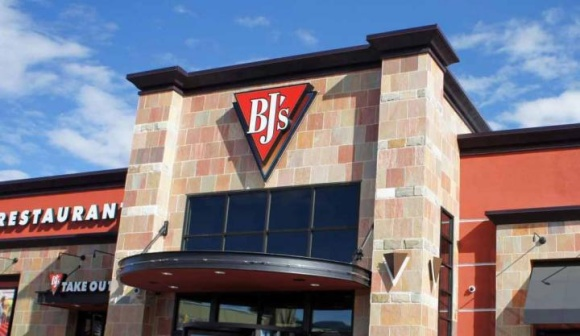Can you describe any specific architectural style or features visible in the picture of the restaurant? The building showcases a modern architectural style with a usage of brick and large glass windows that create a welcoming facade. The triangular logo and the angular designs around the windows add a contemporary edge to the structure. 